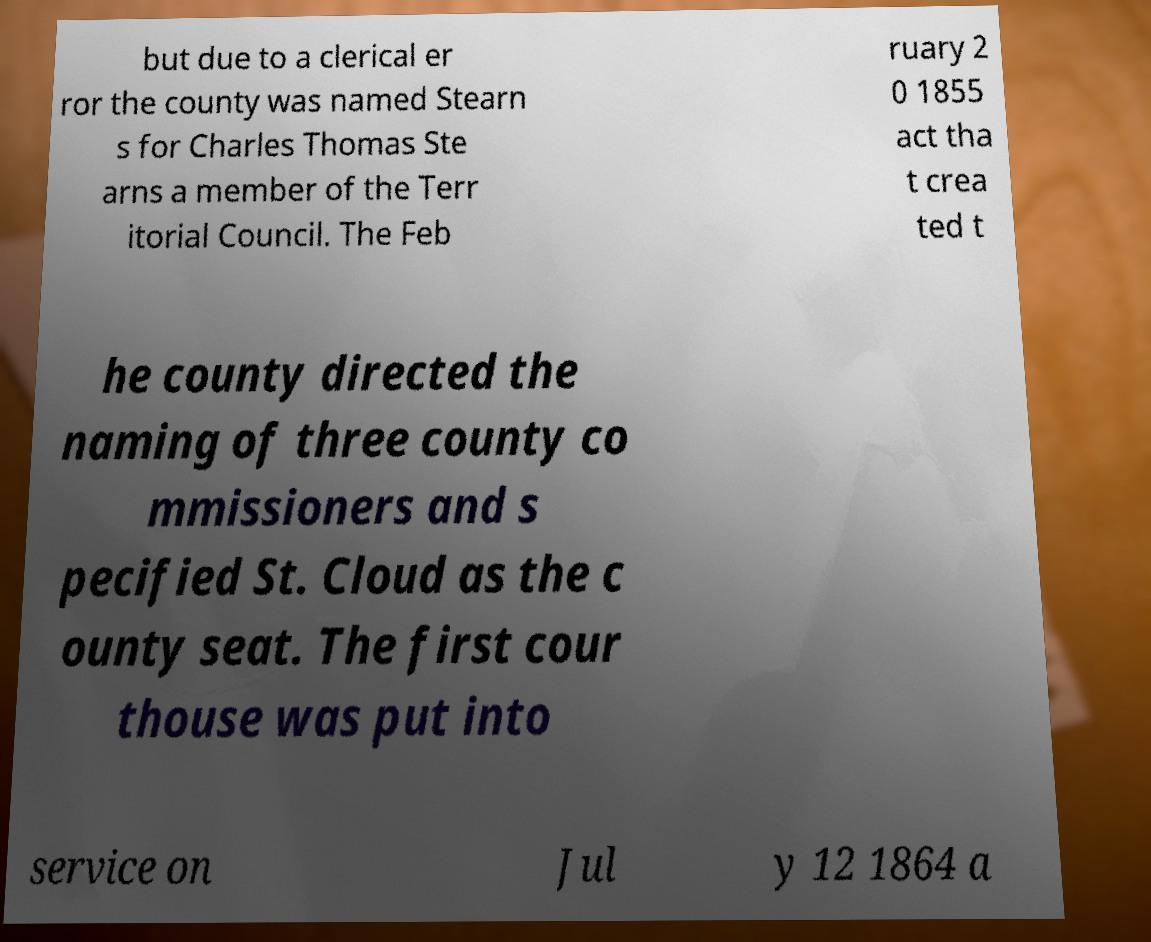What messages or text are displayed in this image? I need them in a readable, typed format. but due to a clerical er ror the county was named Stearn s for Charles Thomas Ste arns a member of the Terr itorial Council. The Feb ruary 2 0 1855 act tha t crea ted t he county directed the naming of three county co mmissioners and s pecified St. Cloud as the c ounty seat. The first cour thouse was put into service on Jul y 12 1864 a 